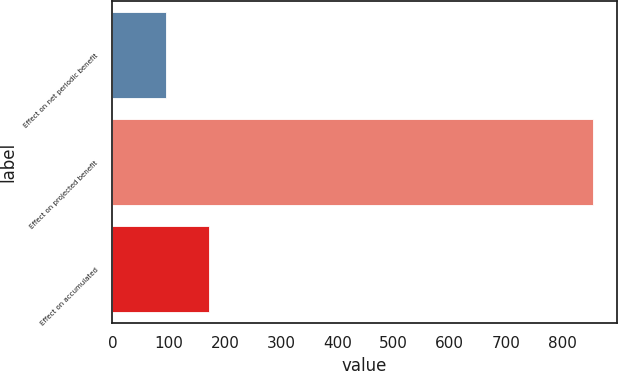Convert chart. <chart><loc_0><loc_0><loc_500><loc_500><bar_chart><fcel>Effect on net periodic benefit<fcel>Effect on projected benefit<fcel>Effect on accumulated<nl><fcel>96<fcel>854<fcel>171.8<nl></chart> 